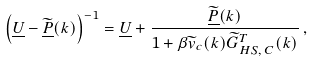Convert formula to latex. <formula><loc_0><loc_0><loc_500><loc_500>\left ( \underline { U } - \widetilde { \underline { P } } ( k ) \right ) ^ { - 1 } = \underline { U } + \frac { \widetilde { \underline { P } } ( k ) } { 1 + \beta \widetilde { v } _ { c } ( k ) \widetilde { G } ^ { T } _ { H S , \, C } ( k ) } \, ,</formula> 